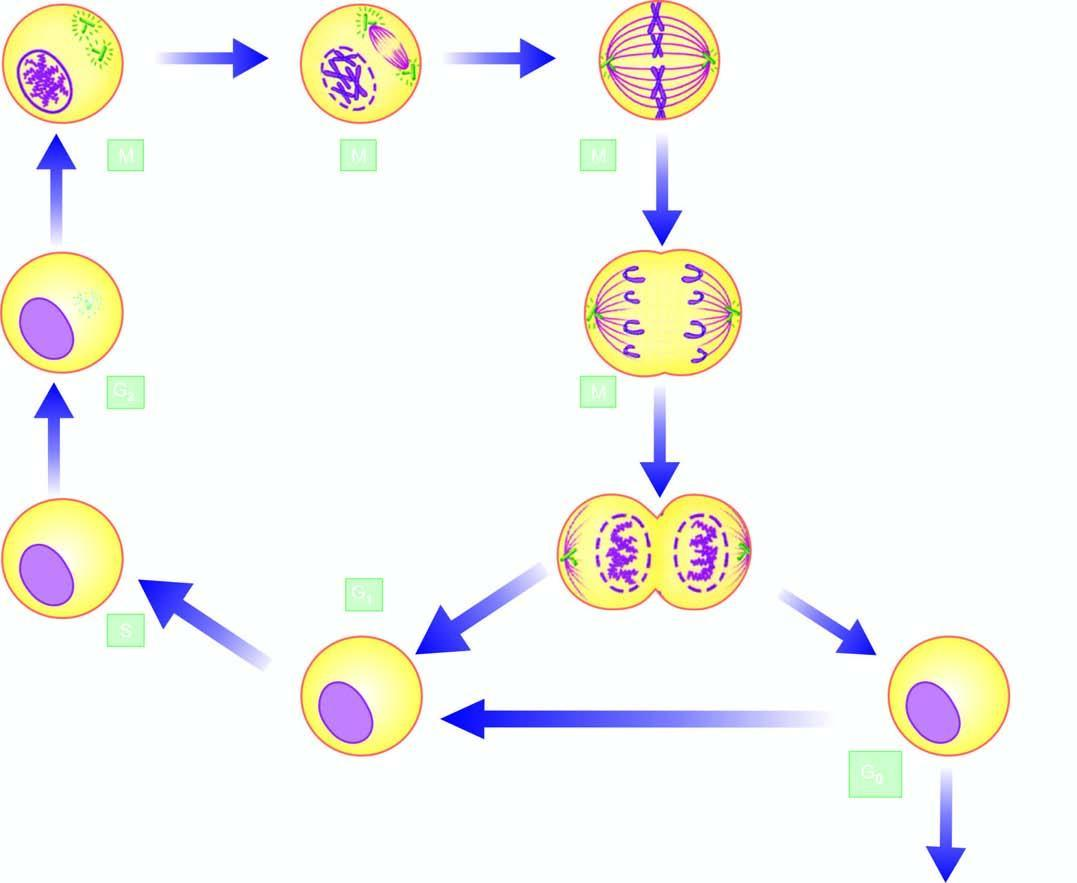re m phase formed which may continue to remain in the cell cycle or go out of it in resting phase interphase, the g0 phase on completion of cell division?
Answer the question using a single word or phrase. No 